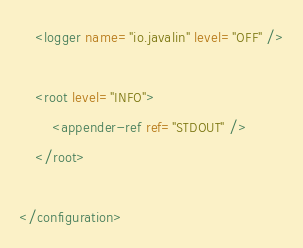<code> <loc_0><loc_0><loc_500><loc_500><_XML_>    <logger name="io.javalin" level="OFF" />

    <root level="INFO">
        <appender-ref ref="STDOUT" />
    </root>

</configuration>
</code> 